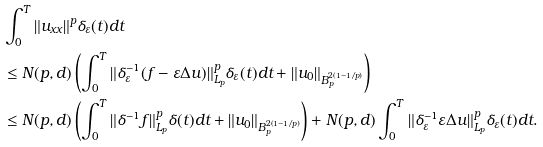Convert formula to latex. <formula><loc_0><loc_0><loc_500><loc_500>& \int ^ { T } _ { 0 } \| u _ { x x } \| ^ { p } \delta _ { \varepsilon } ( t ) d t \\ & \leq N ( p , d ) \left ( \int ^ { T } _ { 0 } \| \delta ^ { - 1 } _ { \varepsilon } ( f - \varepsilon \Delta u ) \| ^ { p } _ { L _ { p } } \delta _ { \varepsilon } ( t ) d t + \| u _ { 0 } \| _ { B _ { p } ^ { 2 \left ( 1 - 1 / p \right ) } } \right ) \\ & \leq N ( p , d ) \left ( \int ^ { T } _ { 0 } \| \delta ^ { - 1 } f \| ^ { p } _ { L _ { p } } \delta ( t ) d t + \| u _ { 0 } \| _ { B _ { p } ^ { 2 \left ( 1 - 1 / p \right ) } } \right ) + N ( p , d ) \int ^ { T } _ { 0 } \| \delta ^ { - 1 } _ { \varepsilon } \varepsilon \Delta u \| ^ { p } _ { L _ { p } } \delta _ { \varepsilon } ( t ) d t .</formula> 